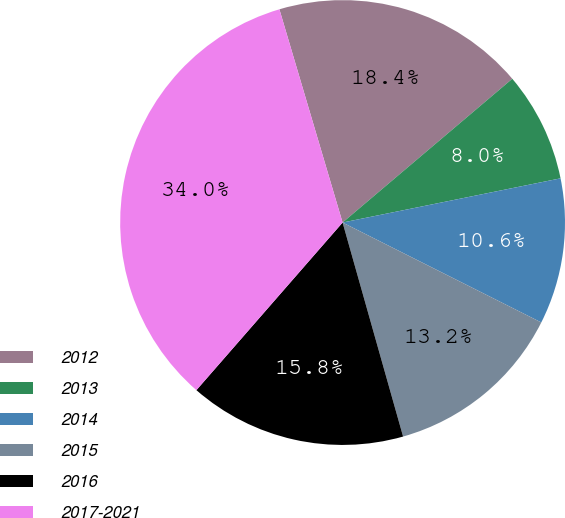<chart> <loc_0><loc_0><loc_500><loc_500><pie_chart><fcel>2012<fcel>2013<fcel>2014<fcel>2015<fcel>2016<fcel>2017-2021<nl><fcel>18.4%<fcel>8.0%<fcel>10.6%<fcel>13.2%<fcel>15.8%<fcel>34.0%<nl></chart> 